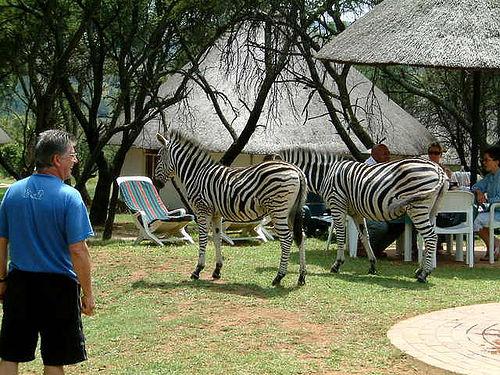Is this a zoo?
Quick response, please. No. What are these animals?
Give a very brief answer. Zebras. What kind of animals?
Concise answer only. Zebra. 